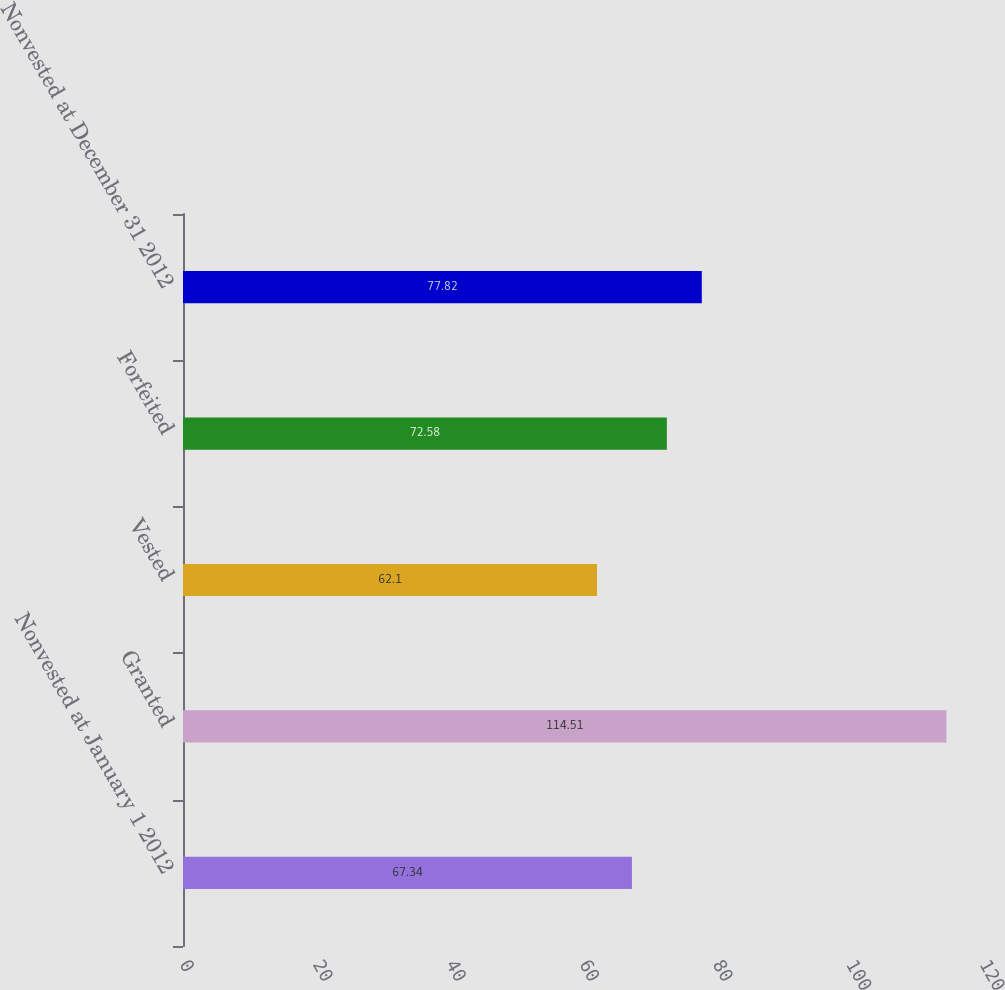<chart> <loc_0><loc_0><loc_500><loc_500><bar_chart><fcel>Nonvested at January 1 2012<fcel>Granted<fcel>Vested<fcel>Forfeited<fcel>Nonvested at December 31 2012<nl><fcel>67.34<fcel>114.51<fcel>62.1<fcel>72.58<fcel>77.82<nl></chart> 